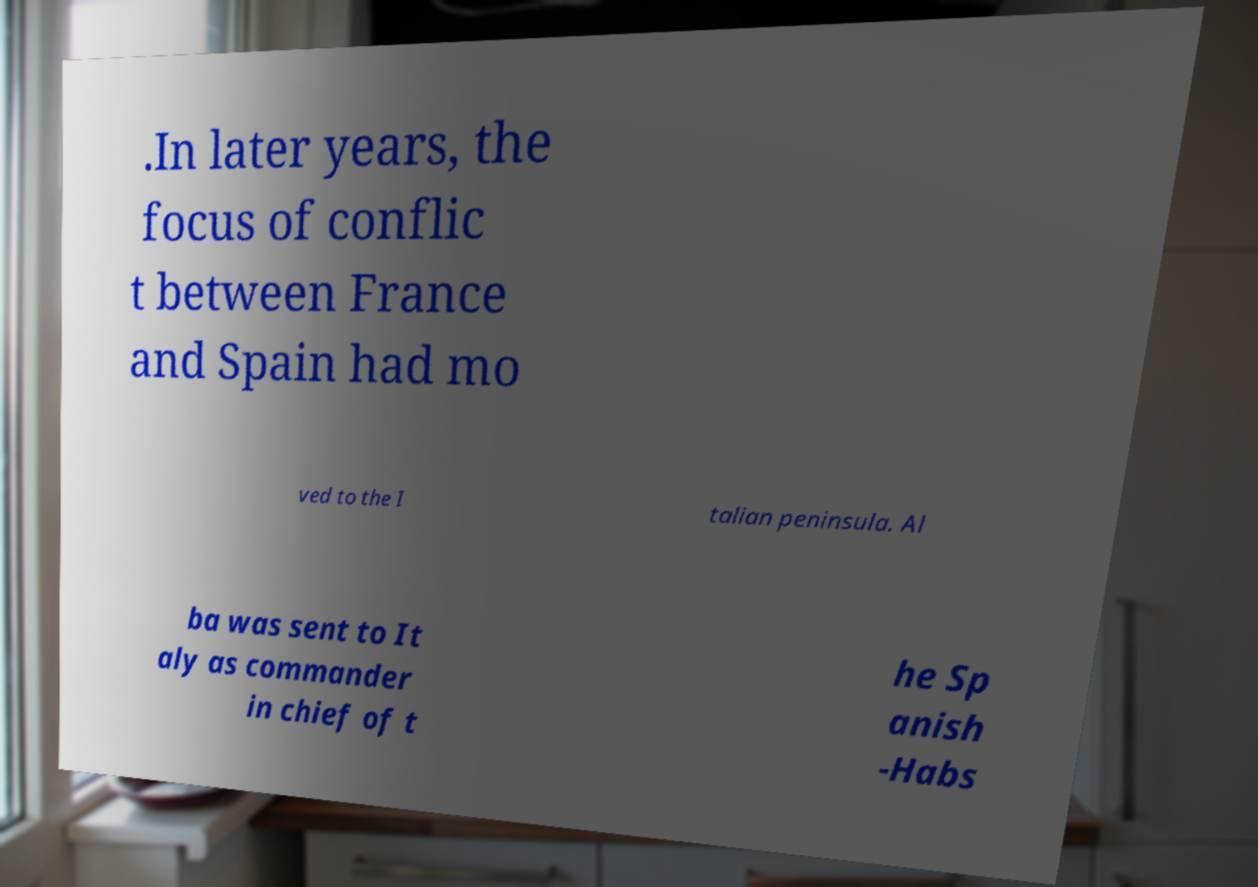What messages or text are displayed in this image? I need them in a readable, typed format. .In later years, the focus of conflic t between France and Spain had mo ved to the I talian peninsula. Al ba was sent to It aly as commander in chief of t he Sp anish -Habs 